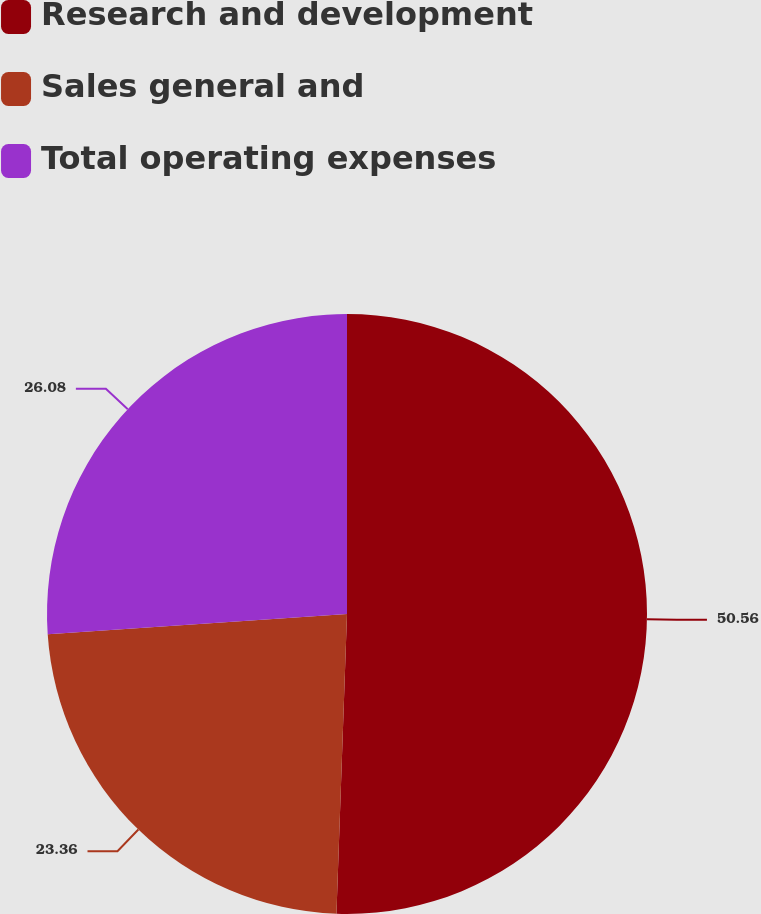Convert chart to OTSL. <chart><loc_0><loc_0><loc_500><loc_500><pie_chart><fcel>Research and development<fcel>Sales general and<fcel>Total operating expenses<nl><fcel>50.56%<fcel>23.36%<fcel>26.08%<nl></chart> 